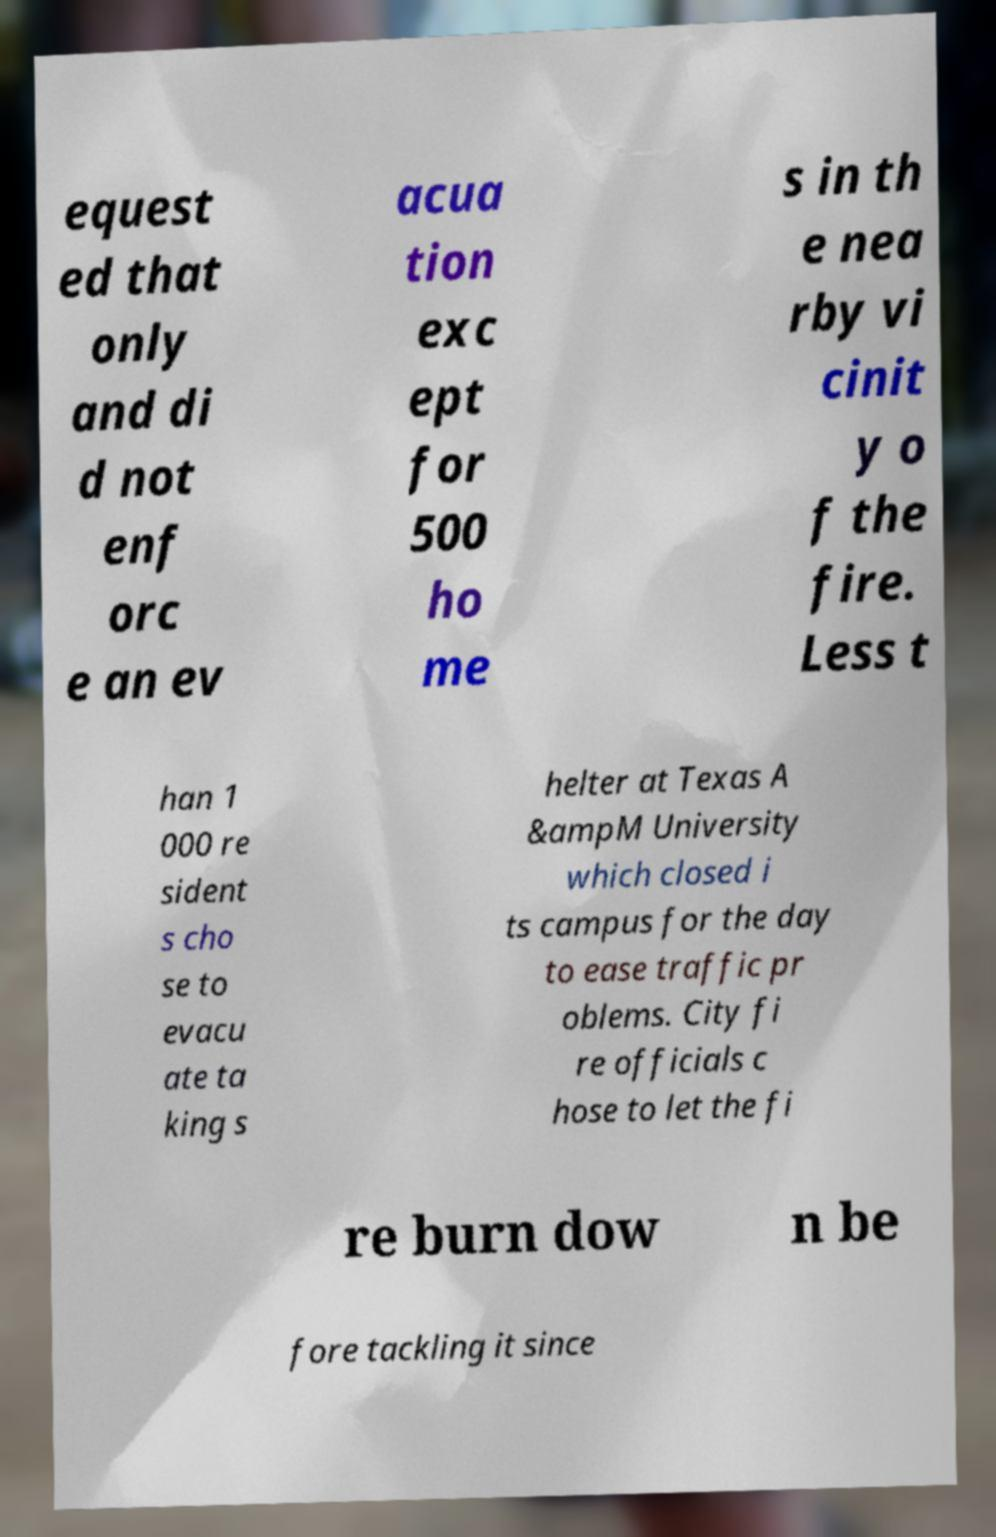Please identify and transcribe the text found in this image. equest ed that only and di d not enf orc e an ev acua tion exc ept for 500 ho me s in th e nea rby vi cinit y o f the fire. Less t han 1 000 re sident s cho se to evacu ate ta king s helter at Texas A &ampM University which closed i ts campus for the day to ease traffic pr oblems. City fi re officials c hose to let the fi re burn dow n be fore tackling it since 